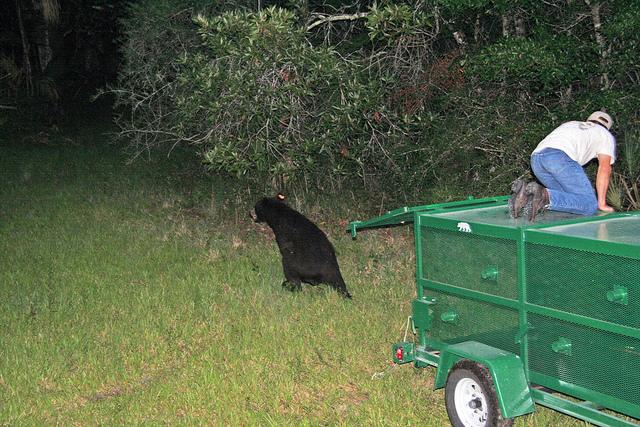What is the man on the trailer feeling?
Quick response, please. Scared. How many wheels are in this picture?
Concise answer only. 1. Is this man trying to catch the animal?
Keep it brief. Yes. 